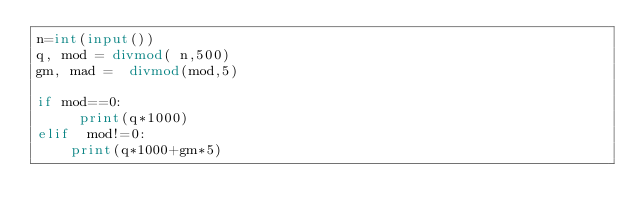<code> <loc_0><loc_0><loc_500><loc_500><_Python_>n=int(input())
q, mod = divmod( n,500)
gm, mad =  divmod(mod,5)

if mod==0:
     print(q*1000)
elif  mod!=0:
    print(q*1000+gm*5)
  </code> 